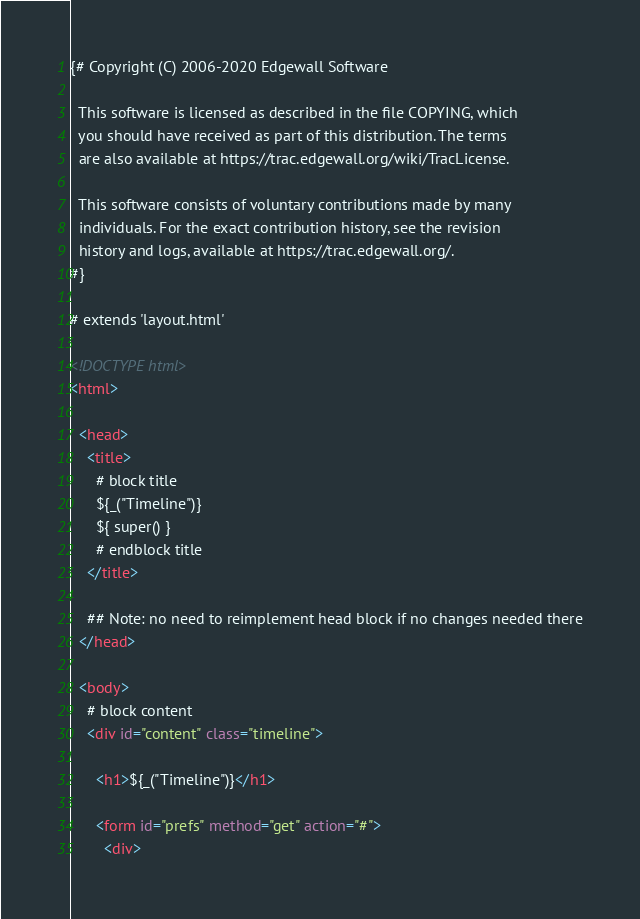<code> <loc_0><loc_0><loc_500><loc_500><_HTML_>{# Copyright (C) 2006-2020 Edgewall Software

  This software is licensed as described in the file COPYING, which
  you should have received as part of this distribution. The terms
  are also available at https://trac.edgewall.org/wiki/TracLicense.

  This software consists of voluntary contributions made by many
  individuals. For the exact contribution history, see the revision
  history and logs, available at https://trac.edgewall.org/.
#}

# extends 'layout.html'

<!DOCTYPE html>
<html>

  <head>
    <title>
      # block title
      ${_("Timeline")}
      ${ super() }
      # endblock title
    </title>

    ## Note: no need to reimplement head block if no changes needed there
  </head>

  <body>
    # block content
    <div id="content" class="timeline">

      <h1>${_("Timeline")}</h1>

      <form id="prefs" method="get" action="#">
        <div></code> 